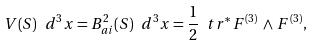<formula> <loc_0><loc_0><loc_500><loc_500>V ( S ) \ d ^ { 3 } x = B _ { a i } ^ { 2 } ( S ) \ d ^ { 3 } x = \frac { 1 } { 2 } \ t r ^ { \ast } \, F ^ { ( 3 ) } \, \wedge \, F ^ { ( 3 ) } ,</formula> 